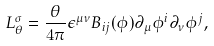<formula> <loc_0><loc_0><loc_500><loc_500>L _ { \theta } ^ { \sigma } = \frac { \theta } { 4 \pi } \epsilon ^ { \mu \nu } B _ { i j } ( \phi ) \partial _ { \mu } \phi ^ { i } \partial _ { \nu } \phi ^ { j } ,</formula> 